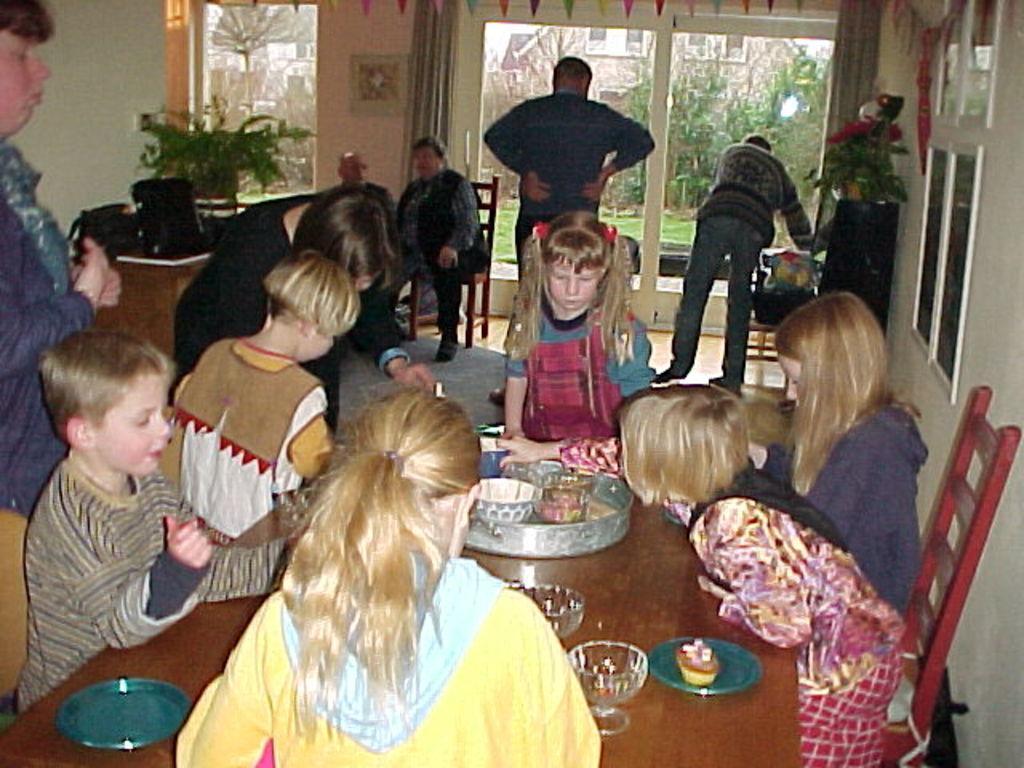In one or two sentences, can you explain what this image depicts? On the background we can see doors, few decorative papers, windows, curtains. here we can see few persons sitting on chairs in front of table and on the table we can see plates, glasses, bowls and this is a cupcake. this is a plant. here we can see few persons standing. 